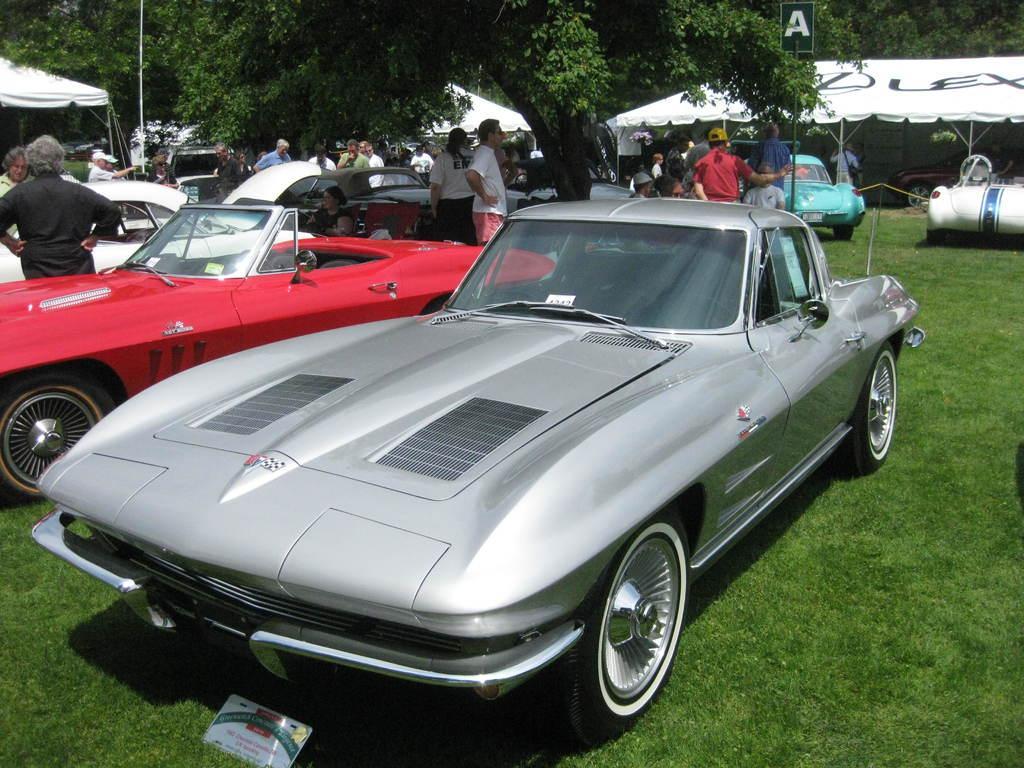Can you describe this image briefly? In the foreground of this image, there are cars on the grass and we can also see few people standing and sitting. At the top, there are few white tents, a board, vehicles and the trees. 